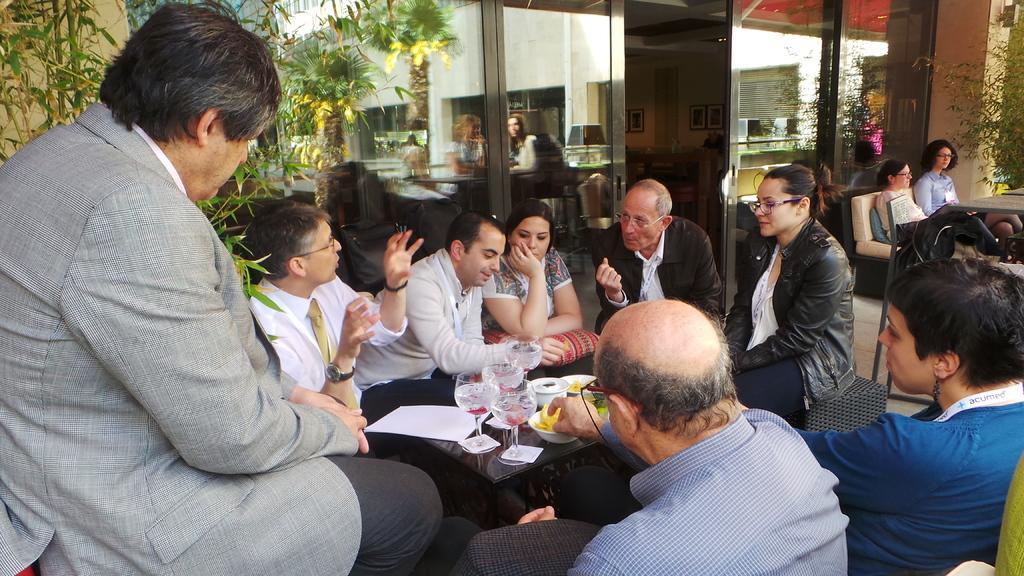How would you summarize this image in a sentence or two? As we can see in the image, there are few group of people sitting around table on chairs. On table there are glasses and bowls. On the left side there is a plant. On the right side there are two women sitting on chairs. 